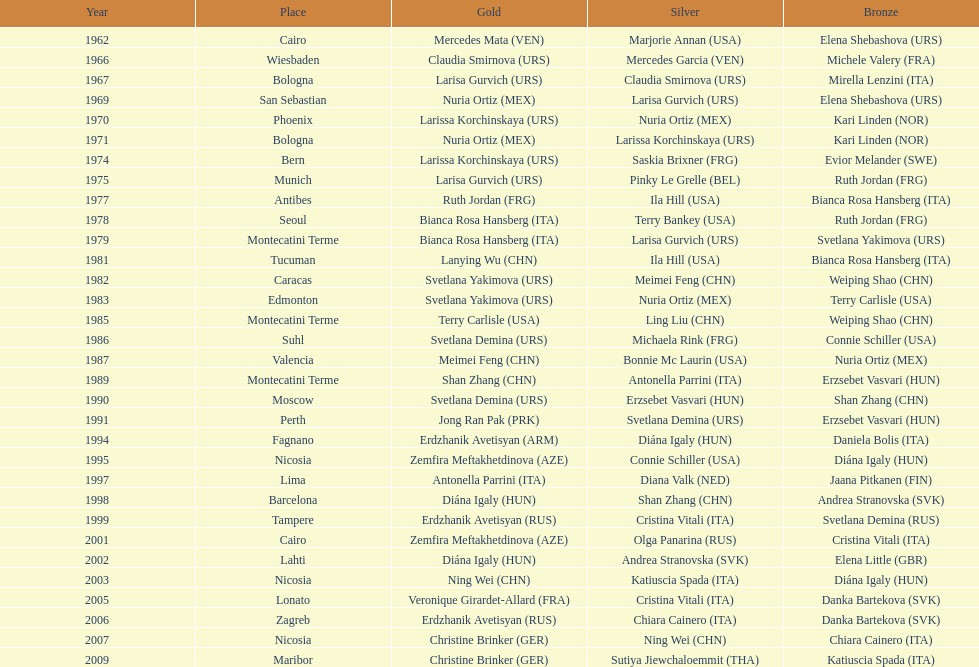What is the aggregate quantity of silver for cairo? 0. 